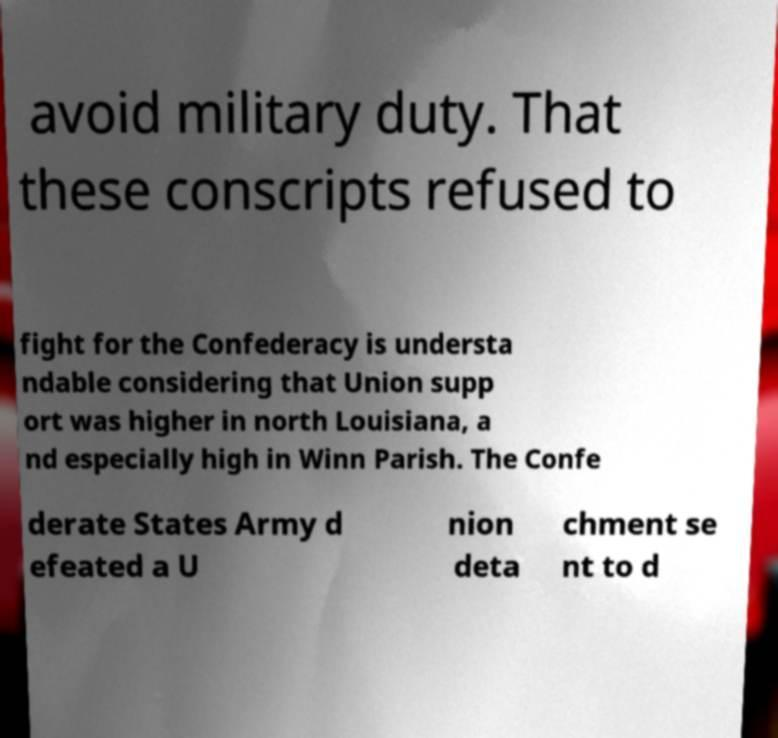There's text embedded in this image that I need extracted. Can you transcribe it verbatim? avoid military duty. That these conscripts refused to fight for the Confederacy is understa ndable considering that Union supp ort was higher in north Louisiana, a nd especially high in Winn Parish. The Confe derate States Army d efeated a U nion deta chment se nt to d 